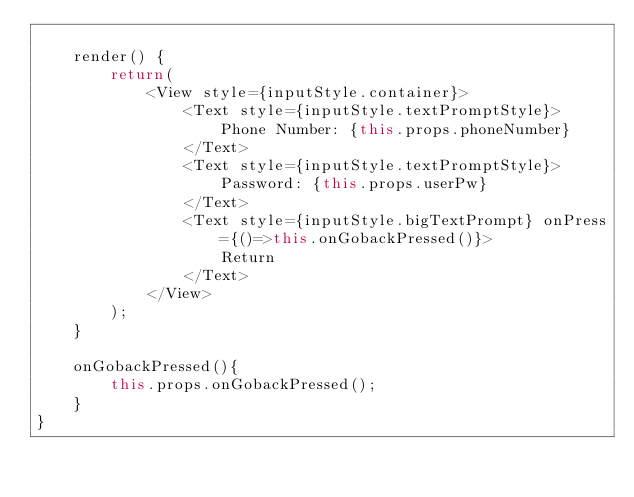Convert code to text. <code><loc_0><loc_0><loc_500><loc_500><_JavaScript_>
    render() {
        return(
            <View style={inputStyle.container}>
                <Text style={inputStyle.textPromptStyle}>
                    Phone Number: {this.props.phoneNumber}
                </Text>
                <Text style={inputStyle.textPromptStyle}>
                    Password: {this.props.userPw}
                </Text>
                <Text style={inputStyle.bigTextPrompt} onPress={()=>this.onGobackPressed()}>
                    Return
                </Text>
            </View>
        );
    }

    onGobackPressed(){
        this.props.onGobackPressed();
    }
}


</code> 